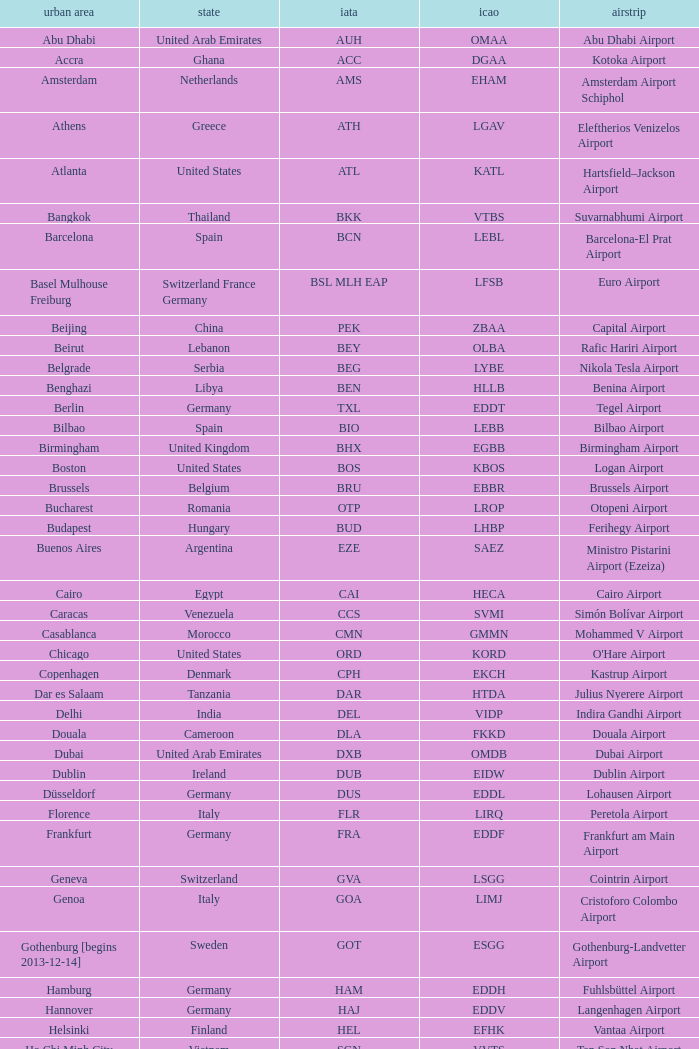Which city has the IATA SSG? Malabo. I'm looking to parse the entire table for insights. Could you assist me with that? {'header': ['urban area', 'state', 'iata', 'icao', 'airstrip'], 'rows': [['Abu Dhabi', 'United Arab Emirates', 'AUH', 'OMAA', 'Abu Dhabi Airport'], ['Accra', 'Ghana', 'ACC', 'DGAA', 'Kotoka Airport'], ['Amsterdam', 'Netherlands', 'AMS', 'EHAM', 'Amsterdam Airport Schiphol'], ['Athens', 'Greece', 'ATH', 'LGAV', 'Eleftherios Venizelos Airport'], ['Atlanta', 'United States', 'ATL', 'KATL', 'Hartsfield–Jackson Airport'], ['Bangkok', 'Thailand', 'BKK', 'VTBS', 'Suvarnabhumi Airport'], ['Barcelona', 'Spain', 'BCN', 'LEBL', 'Barcelona-El Prat Airport'], ['Basel Mulhouse Freiburg', 'Switzerland France Germany', 'BSL MLH EAP', 'LFSB', 'Euro Airport'], ['Beijing', 'China', 'PEK', 'ZBAA', 'Capital Airport'], ['Beirut', 'Lebanon', 'BEY', 'OLBA', 'Rafic Hariri Airport'], ['Belgrade', 'Serbia', 'BEG', 'LYBE', 'Nikola Tesla Airport'], ['Benghazi', 'Libya', 'BEN', 'HLLB', 'Benina Airport'], ['Berlin', 'Germany', 'TXL', 'EDDT', 'Tegel Airport'], ['Bilbao', 'Spain', 'BIO', 'LEBB', 'Bilbao Airport'], ['Birmingham', 'United Kingdom', 'BHX', 'EGBB', 'Birmingham Airport'], ['Boston', 'United States', 'BOS', 'KBOS', 'Logan Airport'], ['Brussels', 'Belgium', 'BRU', 'EBBR', 'Brussels Airport'], ['Bucharest', 'Romania', 'OTP', 'LROP', 'Otopeni Airport'], ['Budapest', 'Hungary', 'BUD', 'LHBP', 'Ferihegy Airport'], ['Buenos Aires', 'Argentina', 'EZE', 'SAEZ', 'Ministro Pistarini Airport (Ezeiza)'], ['Cairo', 'Egypt', 'CAI', 'HECA', 'Cairo Airport'], ['Caracas', 'Venezuela', 'CCS', 'SVMI', 'Simón Bolívar Airport'], ['Casablanca', 'Morocco', 'CMN', 'GMMN', 'Mohammed V Airport'], ['Chicago', 'United States', 'ORD', 'KORD', "O'Hare Airport"], ['Copenhagen', 'Denmark', 'CPH', 'EKCH', 'Kastrup Airport'], ['Dar es Salaam', 'Tanzania', 'DAR', 'HTDA', 'Julius Nyerere Airport'], ['Delhi', 'India', 'DEL', 'VIDP', 'Indira Gandhi Airport'], ['Douala', 'Cameroon', 'DLA', 'FKKD', 'Douala Airport'], ['Dubai', 'United Arab Emirates', 'DXB', 'OMDB', 'Dubai Airport'], ['Dublin', 'Ireland', 'DUB', 'EIDW', 'Dublin Airport'], ['Düsseldorf', 'Germany', 'DUS', 'EDDL', 'Lohausen Airport'], ['Florence', 'Italy', 'FLR', 'LIRQ', 'Peretola Airport'], ['Frankfurt', 'Germany', 'FRA', 'EDDF', 'Frankfurt am Main Airport'], ['Geneva', 'Switzerland', 'GVA', 'LSGG', 'Cointrin Airport'], ['Genoa', 'Italy', 'GOA', 'LIMJ', 'Cristoforo Colombo Airport'], ['Gothenburg [begins 2013-12-14]', 'Sweden', 'GOT', 'ESGG', 'Gothenburg-Landvetter Airport'], ['Hamburg', 'Germany', 'HAM', 'EDDH', 'Fuhlsbüttel Airport'], ['Hannover', 'Germany', 'HAJ', 'EDDV', 'Langenhagen Airport'], ['Helsinki', 'Finland', 'HEL', 'EFHK', 'Vantaa Airport'], ['Ho Chi Minh City', 'Vietnam', 'SGN', 'VVTS', 'Tan Son Nhat Airport'], ['Hong Kong', 'Hong Kong', 'HKG', 'VHHH', 'Chek Lap Kok Airport'], ['Istanbul', 'Turkey', 'IST', 'LTBA', 'Atatürk Airport'], ['Jakarta', 'Indonesia', 'CGK', 'WIII', 'Soekarno–Hatta Airport'], ['Jeddah', 'Saudi Arabia', 'JED', 'OEJN', 'King Abdulaziz Airport'], ['Johannesburg', 'South Africa', 'JNB', 'FAJS', 'OR Tambo Airport'], ['Karachi', 'Pakistan', 'KHI', 'OPKC', 'Jinnah Airport'], ['Kiev', 'Ukraine', 'KBP', 'UKBB', 'Boryspil International Airport'], ['Lagos', 'Nigeria', 'LOS', 'DNMM', 'Murtala Muhammed Airport'], ['Libreville', 'Gabon', 'LBV', 'FOOL', "Leon M'ba Airport"], ['Lisbon', 'Portugal', 'LIS', 'LPPT', 'Portela Airport'], ['London', 'United Kingdom', 'LCY', 'EGLC', 'City Airport'], ['London [begins 2013-12-14]', 'United Kingdom', 'LGW', 'EGKK', 'Gatwick Airport'], ['London', 'United Kingdom', 'LHR', 'EGLL', 'Heathrow Airport'], ['Los Angeles', 'United States', 'LAX', 'KLAX', 'Los Angeles International Airport'], ['Lugano', 'Switzerland', 'LUG', 'LSZA', 'Agno Airport'], ['Luxembourg City', 'Luxembourg', 'LUX', 'ELLX', 'Findel Airport'], ['Lyon', 'France', 'LYS', 'LFLL', 'Saint-Exupéry Airport'], ['Madrid', 'Spain', 'MAD', 'LEMD', 'Madrid-Barajas Airport'], ['Malabo', 'Equatorial Guinea', 'SSG', 'FGSL', 'Saint Isabel Airport'], ['Malaga', 'Spain', 'AGP', 'LEMG', 'Málaga-Costa del Sol Airport'], ['Manchester', 'United Kingdom', 'MAN', 'EGCC', 'Ringway Airport'], ['Manila', 'Philippines', 'MNL', 'RPLL', 'Ninoy Aquino Airport'], ['Marrakech [begins 2013-11-01]', 'Morocco', 'RAK', 'GMMX', 'Menara Airport'], ['Miami', 'United States', 'MIA', 'KMIA', 'Miami Airport'], ['Milan', 'Italy', 'MXP', 'LIMC', 'Malpensa Airport'], ['Minneapolis', 'United States', 'MSP', 'KMSP', 'Minneapolis Airport'], ['Montreal', 'Canada', 'YUL', 'CYUL', 'Pierre Elliott Trudeau Airport'], ['Moscow', 'Russia', 'DME', 'UUDD', 'Domodedovo Airport'], ['Mumbai', 'India', 'BOM', 'VABB', 'Chhatrapati Shivaji Airport'], ['Munich', 'Germany', 'MUC', 'EDDM', 'Franz Josef Strauss Airport'], ['Muscat', 'Oman', 'MCT', 'OOMS', 'Seeb Airport'], ['Nairobi', 'Kenya', 'NBO', 'HKJK', 'Jomo Kenyatta Airport'], ['Newark', 'United States', 'EWR', 'KEWR', 'Liberty Airport'], ['New York City', 'United States', 'JFK', 'KJFK', 'John F Kennedy Airport'], ['Nice', 'France', 'NCE', 'LFMN', "Côte d'Azur Airport"], ['Nuremberg', 'Germany', 'NUE', 'EDDN', 'Nuremberg Airport'], ['Oslo', 'Norway', 'OSL', 'ENGM', 'Gardermoen Airport'], ['Palma de Mallorca', 'Spain', 'PMI', 'LFPA', 'Palma de Mallorca Airport'], ['Paris', 'France', 'CDG', 'LFPG', 'Charles de Gaulle Airport'], ['Porto', 'Portugal', 'OPO', 'LPPR', 'Francisco de Sa Carneiro Airport'], ['Prague', 'Czech Republic', 'PRG', 'LKPR', 'Ruzyně Airport'], ['Riga', 'Latvia', 'RIX', 'EVRA', 'Riga Airport'], ['Rio de Janeiro [resumes 2014-7-14]', 'Brazil', 'GIG', 'SBGL', 'Galeão Airport'], ['Riyadh', 'Saudi Arabia', 'RUH', 'OERK', 'King Khalid Airport'], ['Rome', 'Italy', 'FCO', 'LIRF', 'Leonardo da Vinci Airport'], ['Saint Petersburg', 'Russia', 'LED', 'ULLI', 'Pulkovo Airport'], ['San Francisco', 'United States', 'SFO', 'KSFO', 'San Francisco Airport'], ['Santiago', 'Chile', 'SCL', 'SCEL', 'Comodoro Arturo Benitez Airport'], ['São Paulo', 'Brazil', 'GRU', 'SBGR', 'Guarulhos Airport'], ['Sarajevo', 'Bosnia and Herzegovina', 'SJJ', 'LQSA', 'Butmir Airport'], ['Seattle', 'United States', 'SEA', 'KSEA', 'Sea-Tac Airport'], ['Shanghai', 'China', 'PVG', 'ZSPD', 'Pudong Airport'], ['Singapore', 'Singapore', 'SIN', 'WSSS', 'Changi Airport'], ['Skopje', 'Republic of Macedonia', 'SKP', 'LWSK', 'Alexander the Great Airport'], ['Sofia', 'Bulgaria', 'SOF', 'LBSF', 'Vrazhdebna Airport'], ['Stockholm', 'Sweden', 'ARN', 'ESSA', 'Arlanda Airport'], ['Stuttgart', 'Germany', 'STR', 'EDDS', 'Echterdingen Airport'], ['Taipei', 'Taiwan', 'TPE', 'RCTP', 'Taoyuan Airport'], ['Tehran', 'Iran', 'IKA', 'OIIE', 'Imam Khomeini Airport'], ['Tel Aviv', 'Israel', 'TLV', 'LLBG', 'Ben Gurion Airport'], ['Thessaloniki', 'Greece', 'SKG', 'LGTS', 'Macedonia Airport'], ['Tirana', 'Albania', 'TIA', 'LATI', 'Nënë Tereza Airport'], ['Tokyo', 'Japan', 'NRT', 'RJAA', 'Narita Airport'], ['Toronto', 'Canada', 'YYZ', 'CYYZ', 'Pearson Airport'], ['Tripoli', 'Libya', 'TIP', 'HLLT', 'Tripoli Airport'], ['Tunis', 'Tunisia', 'TUN', 'DTTA', 'Carthage Airport'], ['Turin', 'Italy', 'TRN', 'LIMF', 'Sandro Pertini Airport'], ['Valencia', 'Spain', 'VLC', 'LEVC', 'Valencia Airport'], ['Venice', 'Italy', 'VCE', 'LIPZ', 'Marco Polo Airport'], ['Vienna', 'Austria', 'VIE', 'LOWW', 'Schwechat Airport'], ['Warsaw', 'Poland', 'WAW', 'EPWA', 'Frederic Chopin Airport'], ['Washington DC', 'United States', 'IAD', 'KIAD', 'Dulles Airport'], ['Yaounde', 'Cameroon', 'NSI', 'FKYS', 'Yaounde Nsimalen Airport'], ['Yerevan', 'Armenia', 'EVN', 'UDYZ', 'Zvartnots Airport'], ['Zurich', 'Switzerland', 'ZRH', 'LSZH', 'Zurich Airport']]} 